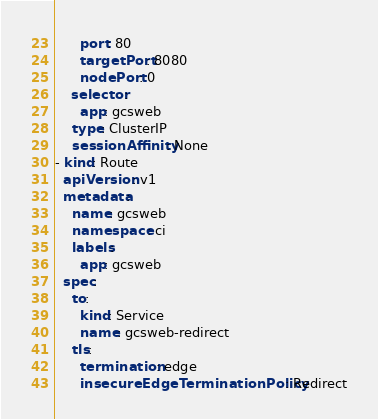<code> <loc_0><loc_0><loc_500><loc_500><_YAML_>      port: 80
      targetPort: 8080
      nodePort: 0
    selector:
      app: gcsweb
    type: ClusterIP
    sessionAffinity: None
- kind: Route
  apiVersion: v1
  metadata:
    name: gcsweb
    namespace: ci
    labels:
      app: gcsweb
  spec:
    to:
      kind: Service
      name: gcsweb-redirect
    tls:
      termination: edge
      insecureEdgeTerminationPolicy: Redirect
</code> 